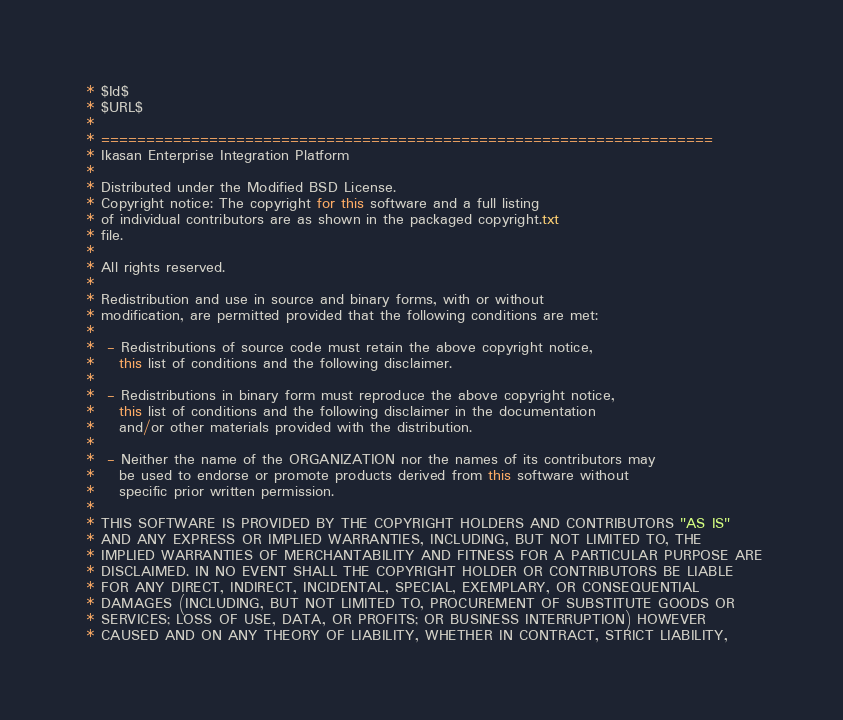Convert code to text. <code><loc_0><loc_0><loc_500><loc_500><_Java_> * $Id$
 * $URL$
 *
 * ====================================================================
 * Ikasan Enterprise Integration Platform
 *
 * Distributed under the Modified BSD License.
 * Copyright notice: The copyright for this software and a full listing
 * of individual contributors are as shown in the packaged copyright.txt
 * file.
 *
 * All rights reserved.
 *
 * Redistribution and use in source and binary forms, with or without
 * modification, are permitted provided that the following conditions are met:
 *
 *  - Redistributions of source code must retain the above copyright notice,
 *    this list of conditions and the following disclaimer.
 *
 *  - Redistributions in binary form must reproduce the above copyright notice,
 *    this list of conditions and the following disclaimer in the documentation
 *    and/or other materials provided with the distribution.
 *
 *  - Neither the name of the ORGANIZATION nor the names of its contributors may
 *    be used to endorse or promote products derived from this software without
 *    specific prior written permission.
 *
 * THIS SOFTWARE IS PROVIDED BY THE COPYRIGHT HOLDERS AND CONTRIBUTORS "AS IS"
 * AND ANY EXPRESS OR IMPLIED WARRANTIES, INCLUDING, BUT NOT LIMITED TO, THE
 * IMPLIED WARRANTIES OF MERCHANTABILITY AND FITNESS FOR A PARTICULAR PURPOSE ARE
 * DISCLAIMED. IN NO EVENT SHALL THE COPYRIGHT HOLDER OR CONTRIBUTORS BE LIABLE
 * FOR ANY DIRECT, INDIRECT, INCIDENTAL, SPECIAL, EXEMPLARY, OR CONSEQUENTIAL
 * DAMAGES (INCLUDING, BUT NOT LIMITED TO, PROCUREMENT OF SUBSTITUTE GOODS OR
 * SERVICES; LOSS OF USE, DATA, OR PROFITS; OR BUSINESS INTERRUPTION) HOWEVER
 * CAUSED AND ON ANY THEORY OF LIABILITY, WHETHER IN CONTRACT, STRICT LIABILITY,</code> 